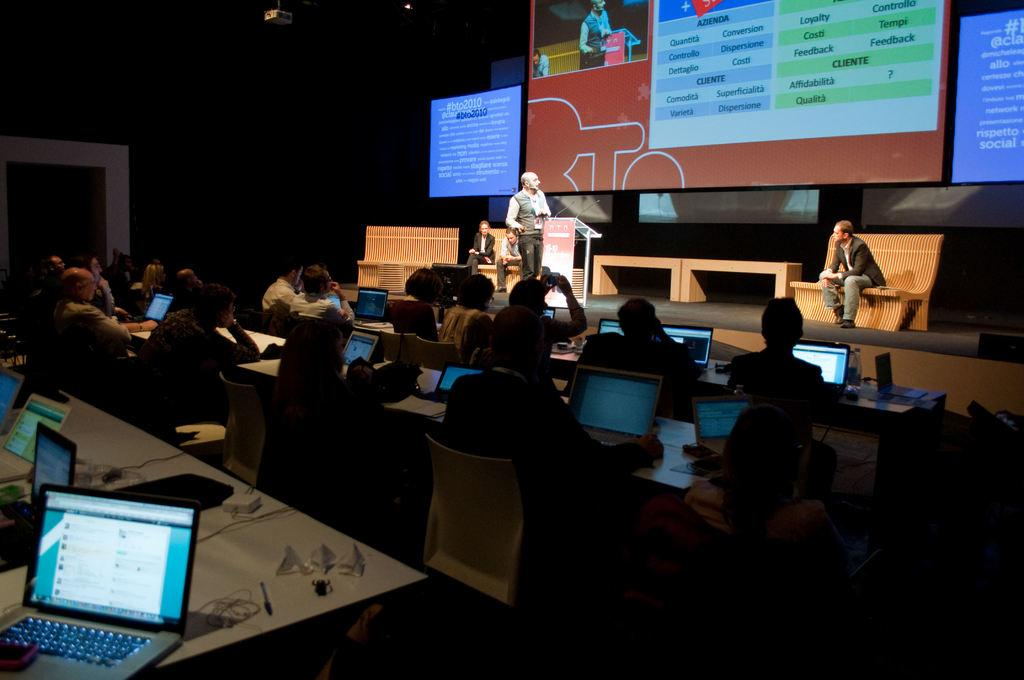Provide a one-sentence caption for the provided image. An instructor stands next to a podium labeled BTO as students listen. 